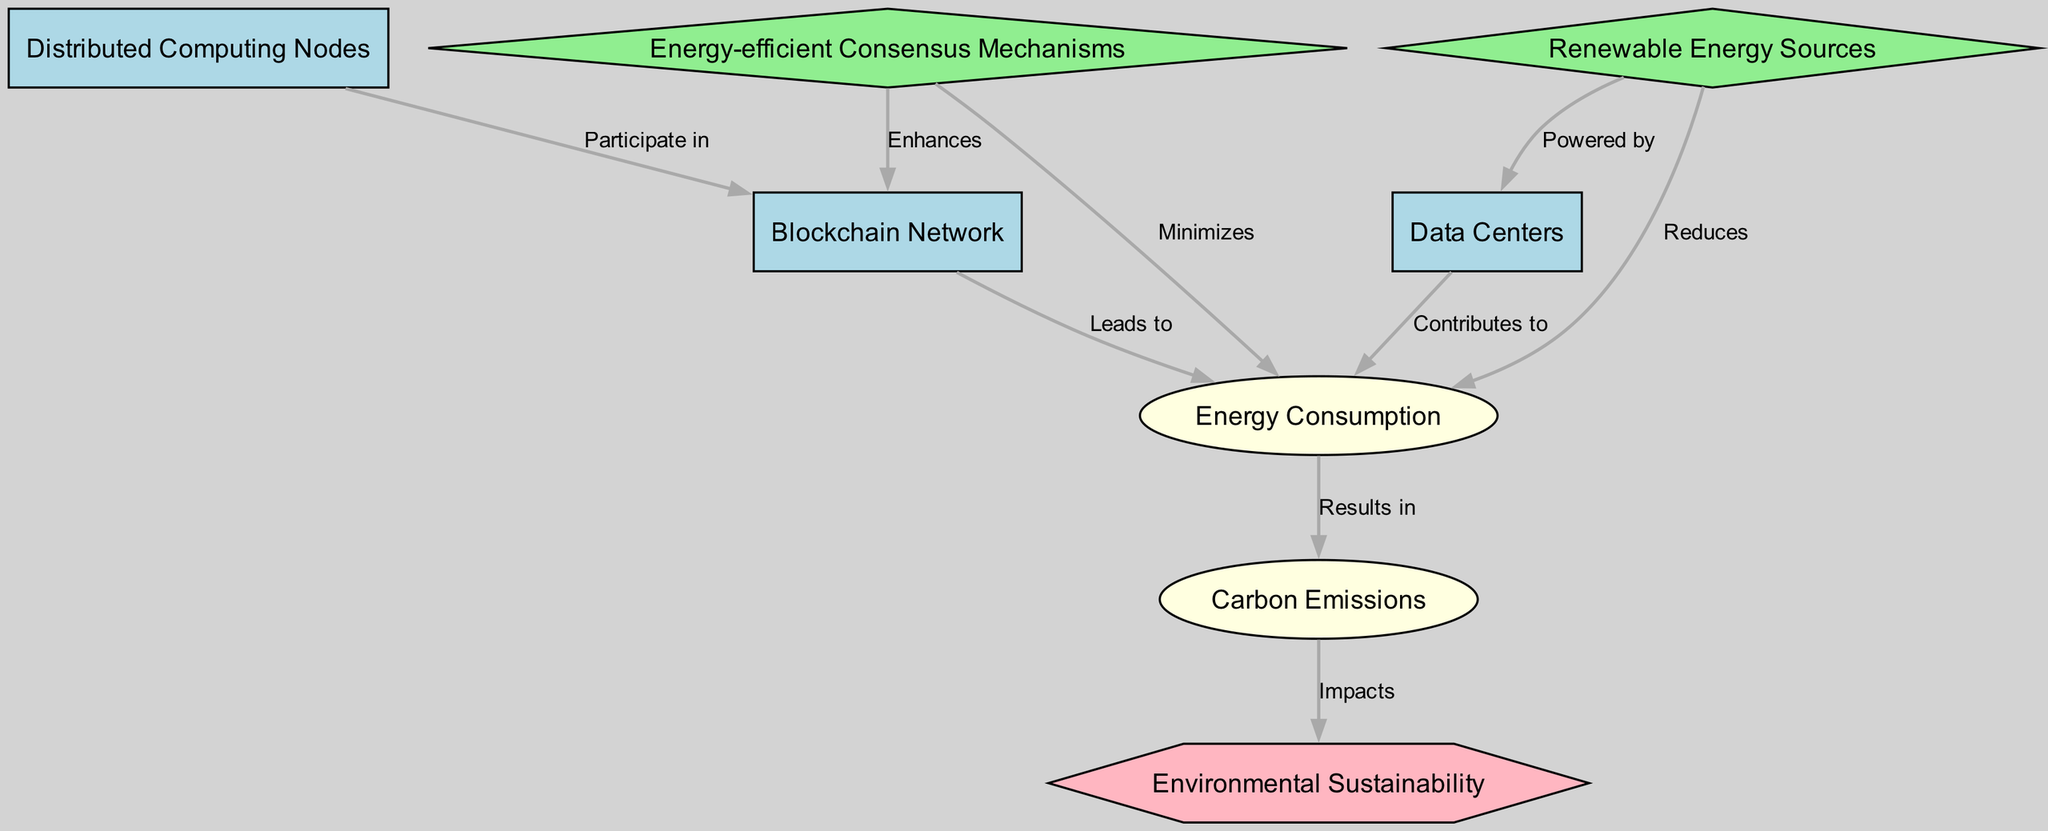What is the main goal of the diagram? The main goal is represented by the node labeled "Environmental Sustainability," which is the ultimate objective that the diagram is structured around.
Answer: Environmental Sustainability How many nodes are present in the diagram? By counting the labeled entities and factors in the diagram, there are eight distinct nodes total.
Answer: 8 What does the "Blockchain Network" lead to? The "Blockchain Network" leads to the "Energy Consumption" node, indicating a direct relationship where the presence of a blockchain network results in energy usage.
Answer: Energy Consumption Which action reduces energy consumption? The action labeled "Renewable Energy Sources" is specified in the diagram as reducing energy consumption through the utilization of sustainable energy options.
Answer: Renewable Energy Sources What is impacted by carbon emissions? The "Environmental Sustainability" node is impacted by "Carbon Emissions," showing that carbon emissions affect the overall sustainability of the environment negatively.
Answer: Environmental Sustainability What do "Energy-efficient Consensus Mechanisms" enhance? The "Energy-efficient Consensus Mechanisms" enhance the "Blockchain Network," indicating that they improve the efficiency and performance of how the network operates.
Answer: Blockchain Network How do data centers contribute to energy consumption? The node "Data Centers" is shown to contribute to "Energy Consumption," illustrating that they are significant consumers of energy within the network.
Answer: Energy Consumption What relationship exists between renewable energy sources and data centers? The relationship is that renewable energy sources power data centers, connecting sustainable energy usage directly to the operation of data centers.
Answer: Powered by What do carbon emissions result in? Carbon emissions result in "Environmental Sustainability" being impacted negatively, showing the cascading effect of emissions on sustainability efforts.
Answer: Environmental Sustainability Which factor minimizes energy consumption? "Energy-efficient Consensus Mechanisms" are the specified factor that minimizes energy consumption by utilizing more efficient methods in the blockchain process.
Answer: Energy-efficient Consensus Mechanisms 